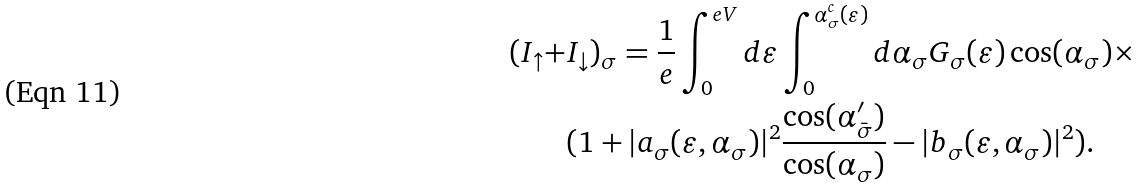Convert formula to latex. <formula><loc_0><loc_0><loc_500><loc_500>( I _ { \uparrow } + & I _ { \downarrow } ) _ { \sigma } = \frac { 1 } { e } \int ^ { e V } _ { 0 } d \varepsilon \int ^ { \alpha _ { \sigma } ^ { c } ( \varepsilon ) } _ { 0 } d \alpha _ { \sigma } { G _ { \sigma } ( \varepsilon ) } \cos ( \alpha _ { \sigma } ) \times \\ & ( 1 + | a _ { \sigma } ( \varepsilon , \alpha _ { \sigma } ) | ^ { 2 } \frac { \cos ( \alpha ^ { \prime } _ { \bar { \sigma } } ) } { \cos ( \alpha _ { \sigma } ) } - | b _ { \sigma } ( \varepsilon , \alpha _ { \sigma } ) | ^ { 2 } ) .</formula> 